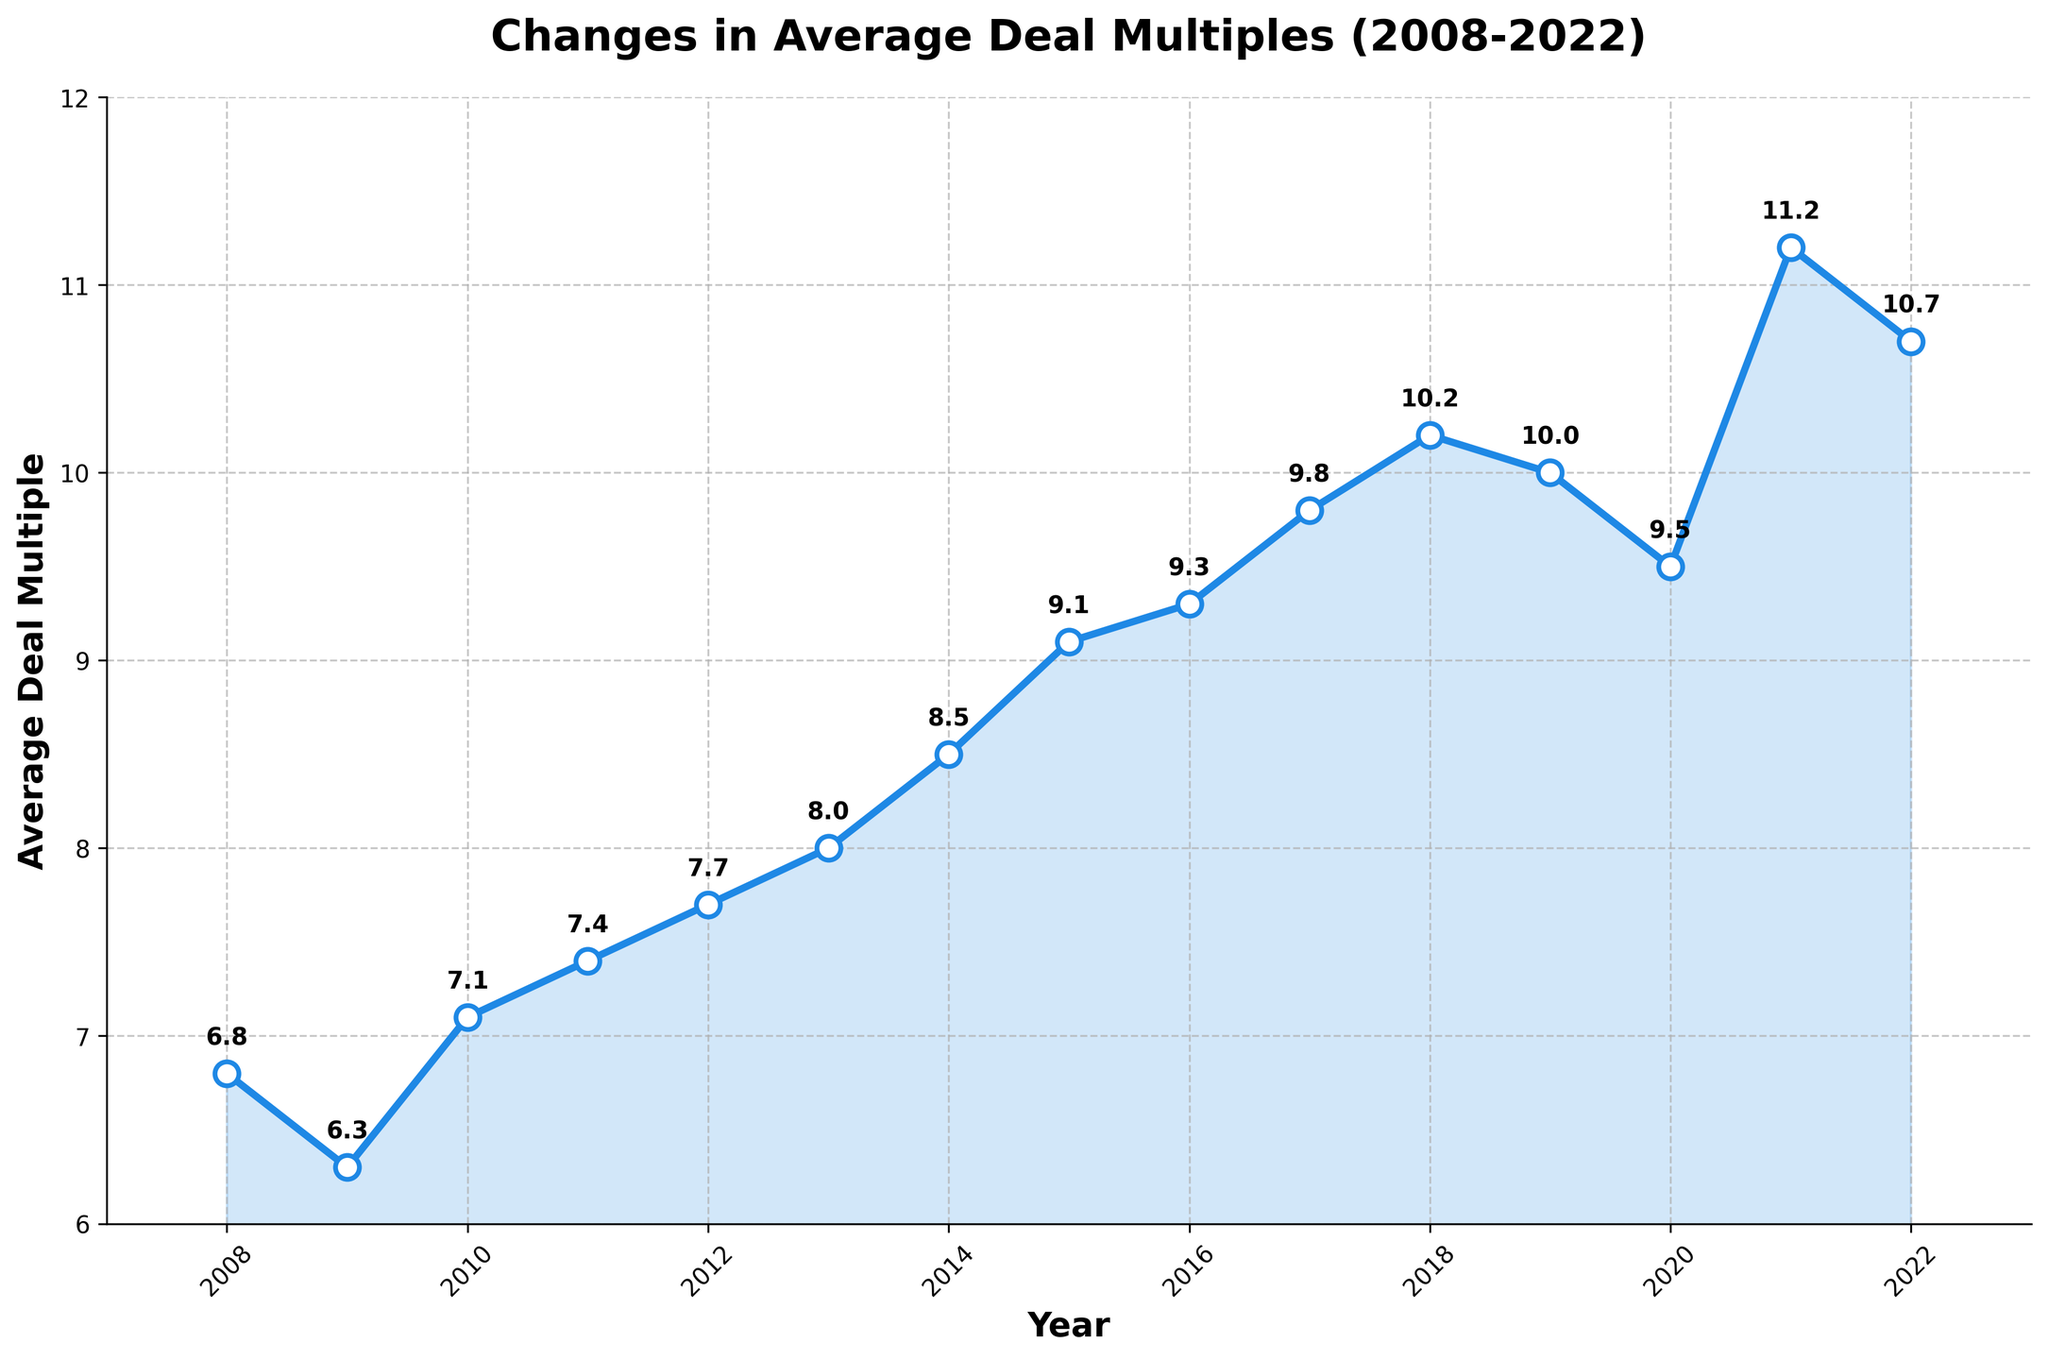What year had the highest average deal multiple? The highest average deal multiple can be identified by looking for the peak on the line chart. The highest peak is in 2021, with an average deal multiple of 11.2.
Answer: 2021 How did the average deal multiple change from 2008 to 2009? To find the change, subtract the value in 2009 from the value in 2008: 6.8 (2008) - 6.3 (2009) = 0.5. The average deal multiple decreased by 0.5 from 2008 to 2009.
Answer: Decreased by 0.5 What is the trend in average deal multiples between 2017 and 2020? To identify the trend, observe the changes in values year-by-year: 9.8 (2017), 10.2 (2018), 10.0 (2019), and 9.5 (2020). The trend shows initial increase from 2017 to 2018 followed by a gradual decrease until 2020.
Answer: Initial increase, then decrease Which years had the same average deal multiple? By examining the chart, both the years 2011 and 2022 show the same average deal multiple of 10.7.
Answer: 2011 and 2022 What is the overall trend observed from 2008 to 2022? To determine the overall trend, observe the general direction of the line. The average deal multiples generally increased with some fluctuations, achieving a maximum in 2021 before slightly decreasing in 2022.
Answer: Generally increasing with some fluctuations In which year did the average deal multiple first exceed 10? Look for the first year in which the value crosses 10. The chart shows it first exceeds 10 in 2018.
Answer: 2018 What is the difference in average deal multiple between 2019 and 2021? Subtract the value for 2019 from the value for 2021: 11.2 (2021) - 10.0 (2019) = 1.2. The difference is 1.2.
Answer: 1.2 Which year shows the lowest average deal multiple among the displayed years? Identify the lowest point on the line chart. The lowest average deal multiple is in 2009 with a value of 6.3.
Answer: 2009 